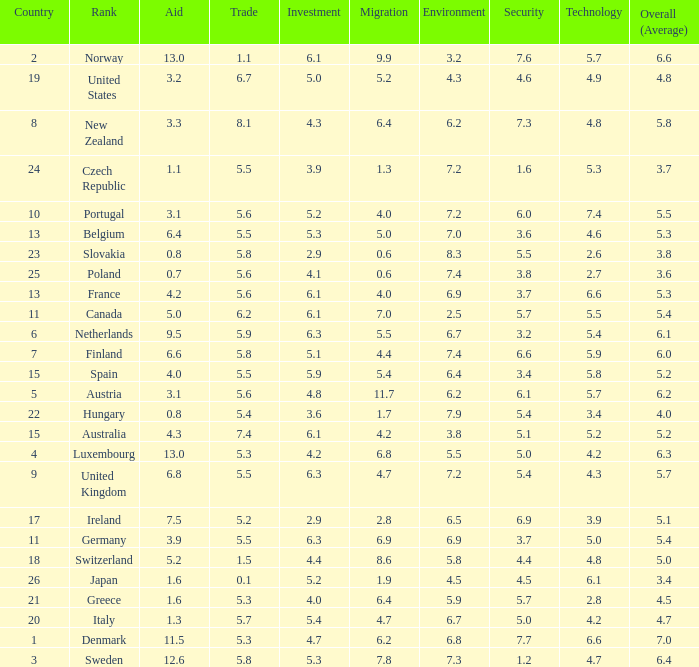How many times is denmark ranked in technology? 1.0. 